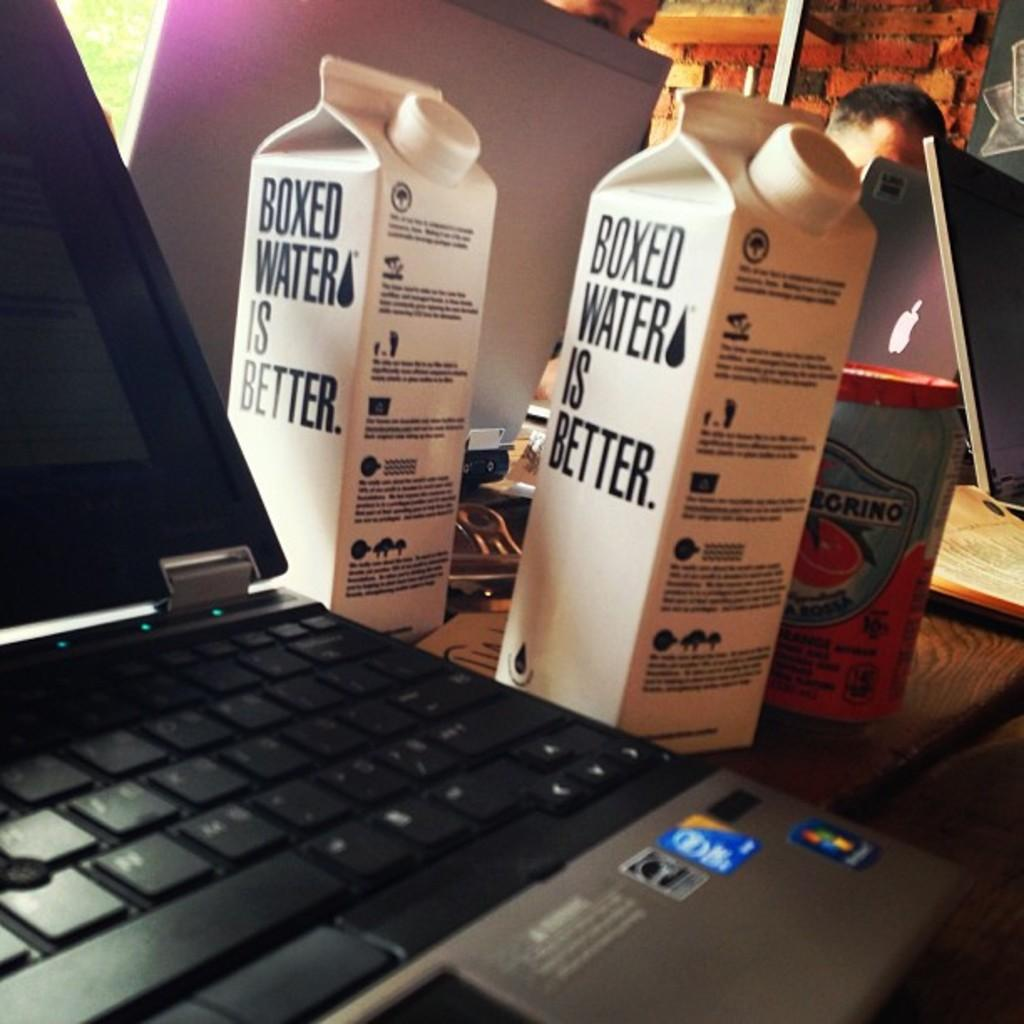<image>
Share a concise interpretation of the image provided. A laptop computer on a desk with 2 containers beside it with the words boxed water is better on them. 